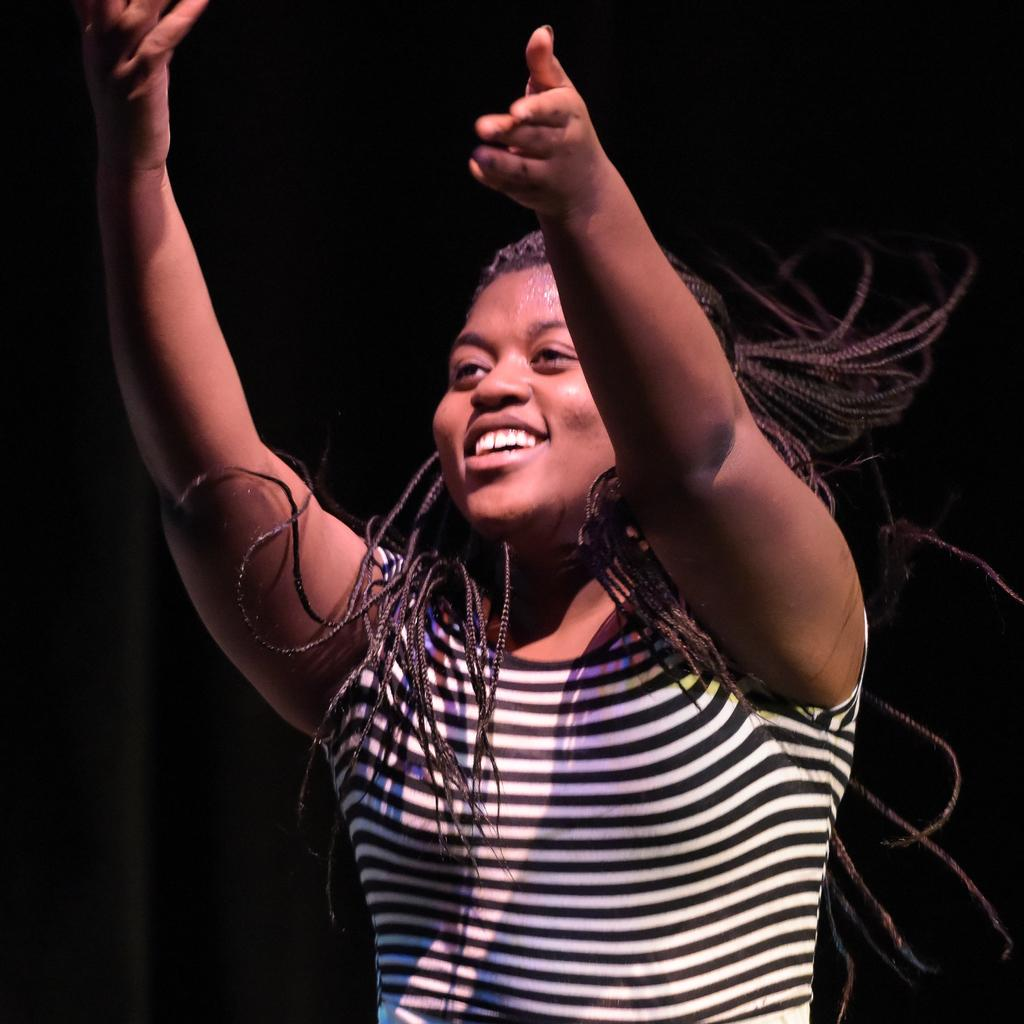Who is the main subject in the image? There is a woman in the image. What is the woman doing in the image? The woman is standing and smiling. Where is the woman located in the image? The woman is in the center of the image. What type of wound can be seen on the woman's face in the image? There is no wound visible on the woman's face in the image. What kind of cake is the woman holding in the image? The woman is not holding a cake in the image. 